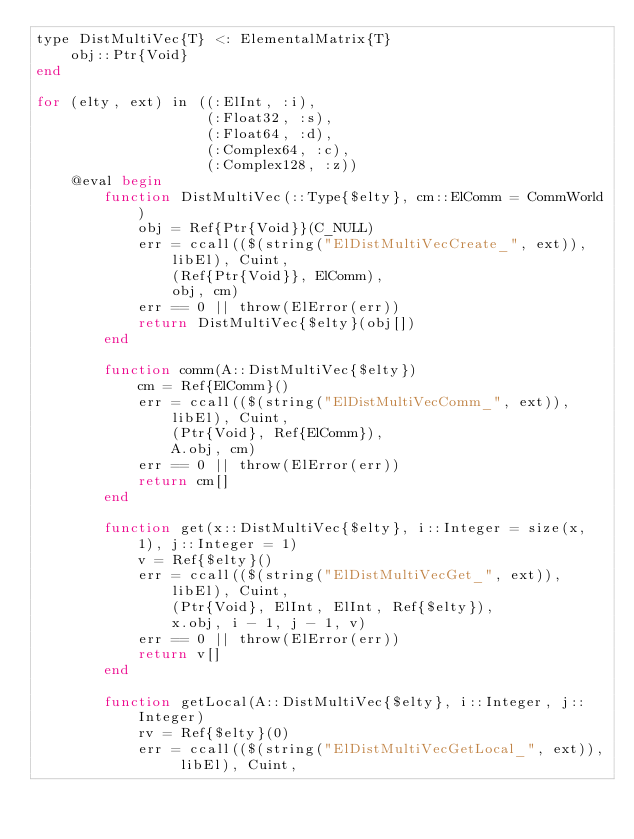<code> <loc_0><loc_0><loc_500><loc_500><_Julia_>type DistMultiVec{T} <: ElementalMatrix{T}
    obj::Ptr{Void}
end

for (elty, ext) in ((:ElInt, :i),
                    (:Float32, :s),
                    (:Float64, :d),
                    (:Complex64, :c),
                    (:Complex128, :z))
    @eval begin
        function DistMultiVec(::Type{$elty}, cm::ElComm = CommWorld)
            obj = Ref{Ptr{Void}}(C_NULL)
            err = ccall(($(string("ElDistMultiVecCreate_", ext)), libEl), Cuint,
                (Ref{Ptr{Void}}, ElComm),
                obj, cm)
            err == 0 || throw(ElError(err))
            return DistMultiVec{$elty}(obj[])
        end

        function comm(A::DistMultiVec{$elty})
            cm = Ref{ElComm}()
            err = ccall(($(string("ElDistMultiVecComm_", ext)), libEl), Cuint,
                (Ptr{Void}, Ref{ElComm}),
                A.obj, cm)
            err == 0 || throw(ElError(err))
            return cm[]
        end

        function get(x::DistMultiVec{$elty}, i::Integer = size(x, 1), j::Integer = 1)
            v = Ref{$elty}()
            err = ccall(($(string("ElDistMultiVecGet_", ext)), libEl), Cuint,
                (Ptr{Void}, ElInt, ElInt, Ref{$elty}),
                x.obj, i - 1, j - 1, v)
            err == 0 || throw(ElError(err))
            return v[]
        end

        function getLocal(A::DistMultiVec{$elty}, i::Integer, j::Integer)
            rv = Ref{$elty}(0)
            err = ccall(($(string("ElDistMultiVecGetLocal_", ext)), libEl), Cuint,</code> 